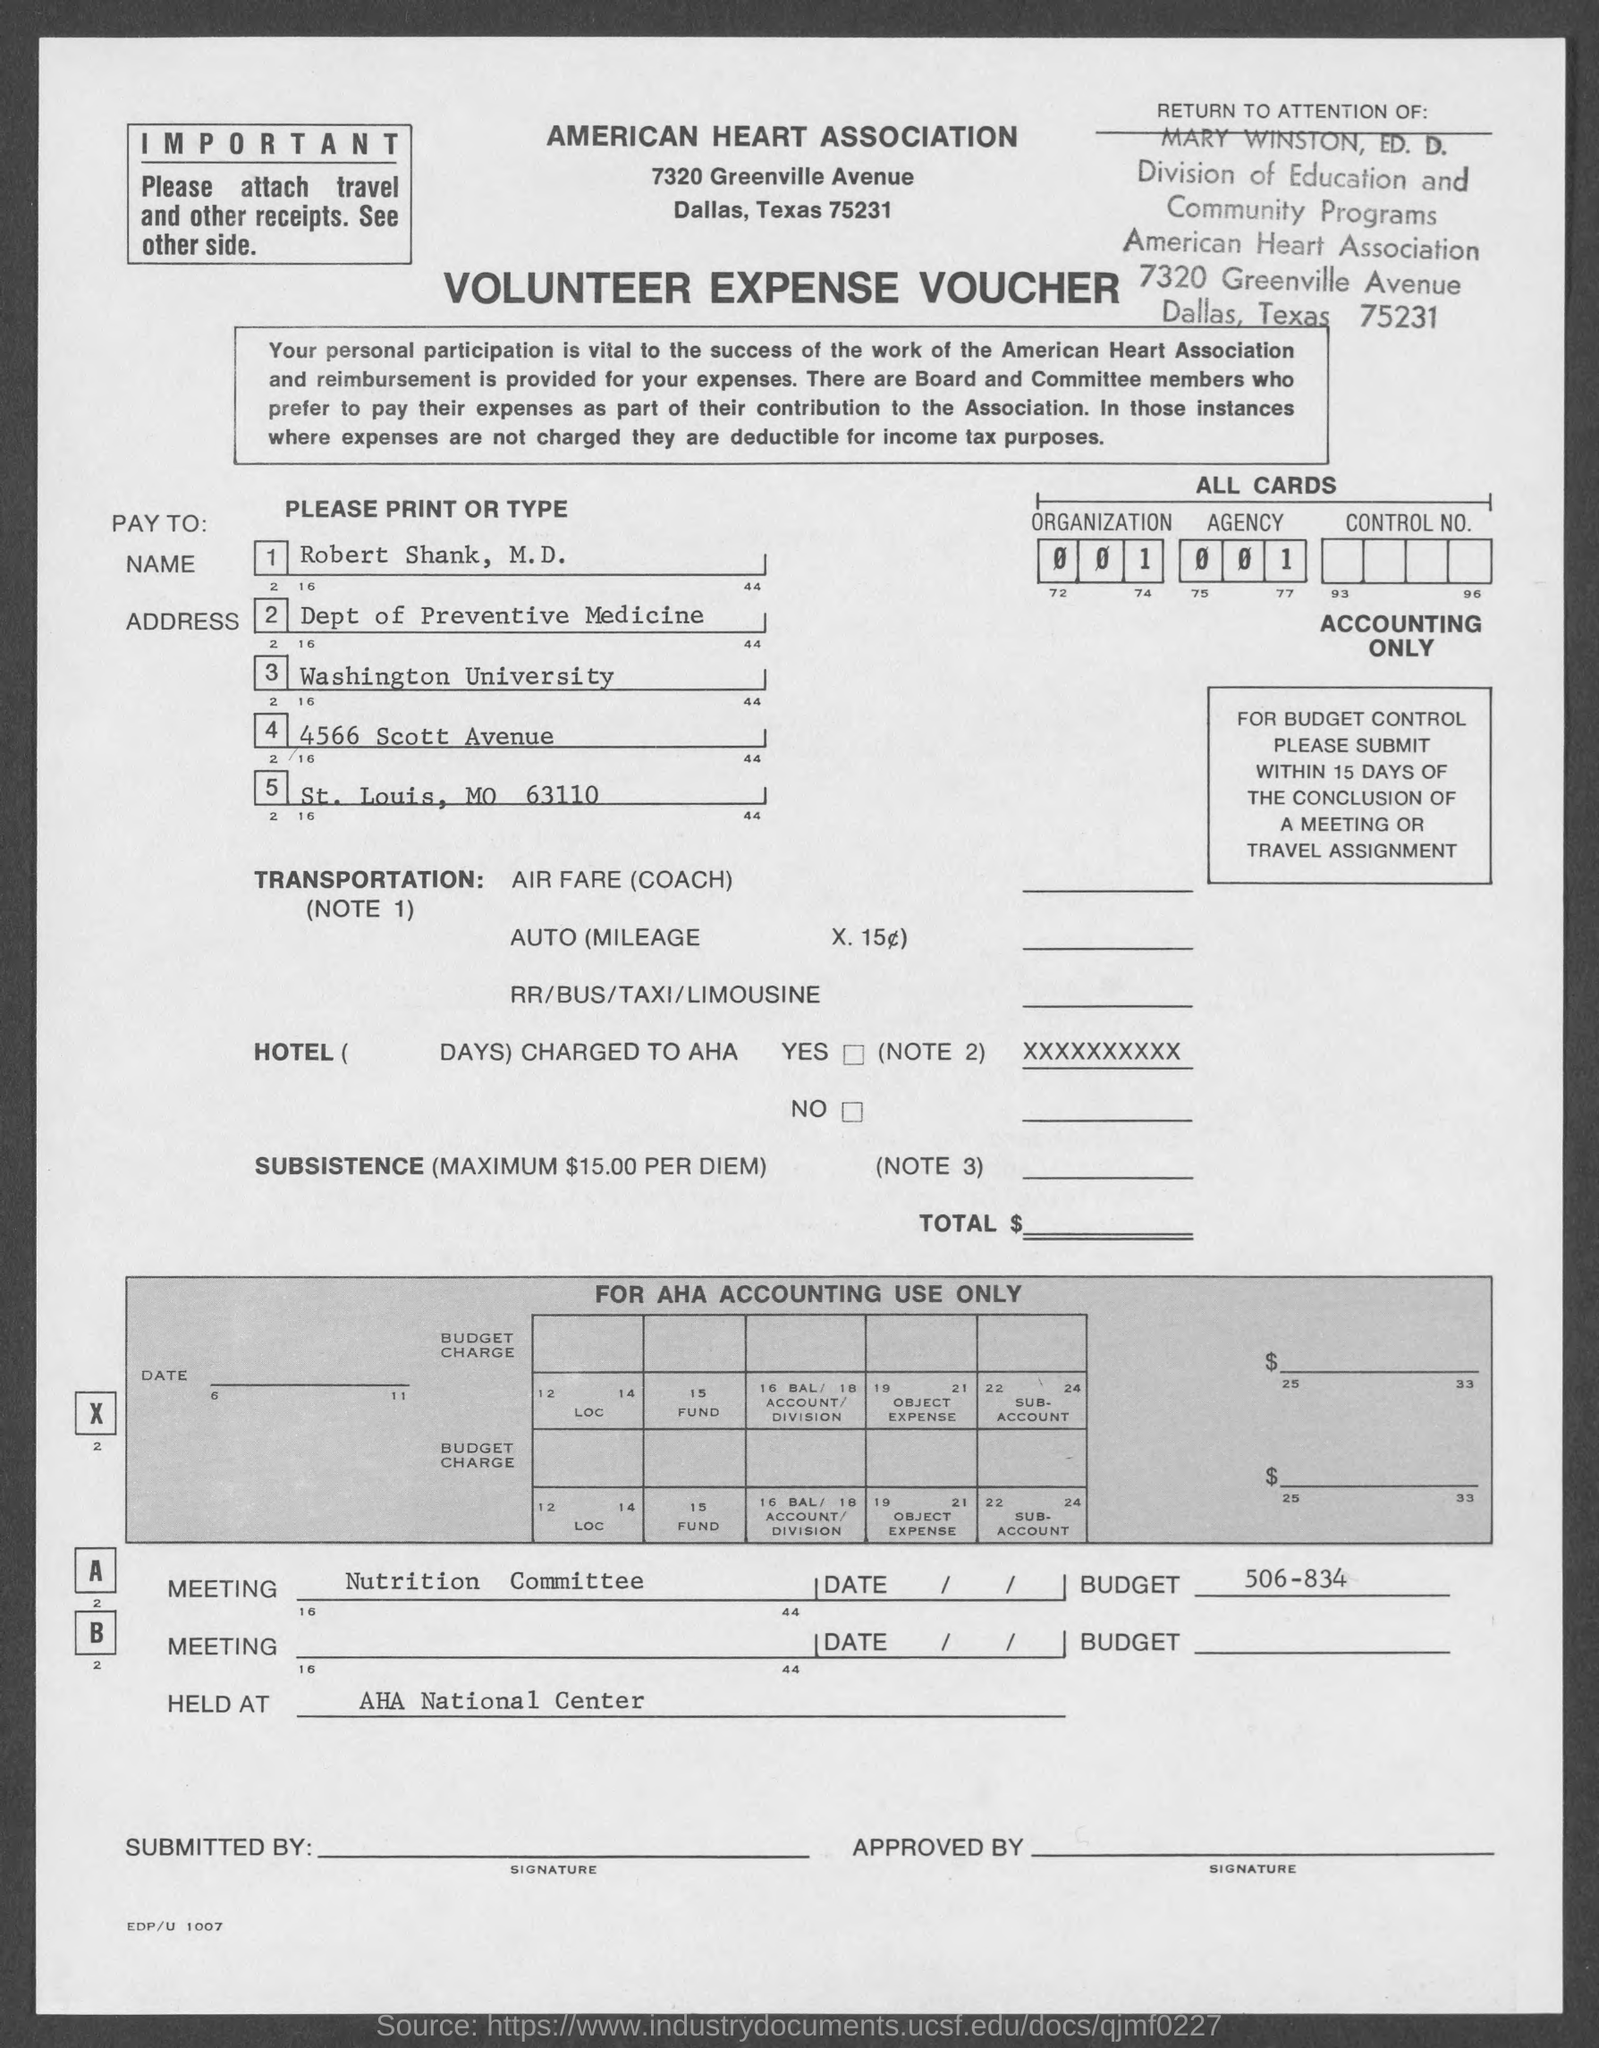Give some essential details in this illustration. The Meeting Field contains the written text "Nutrition Committee. 